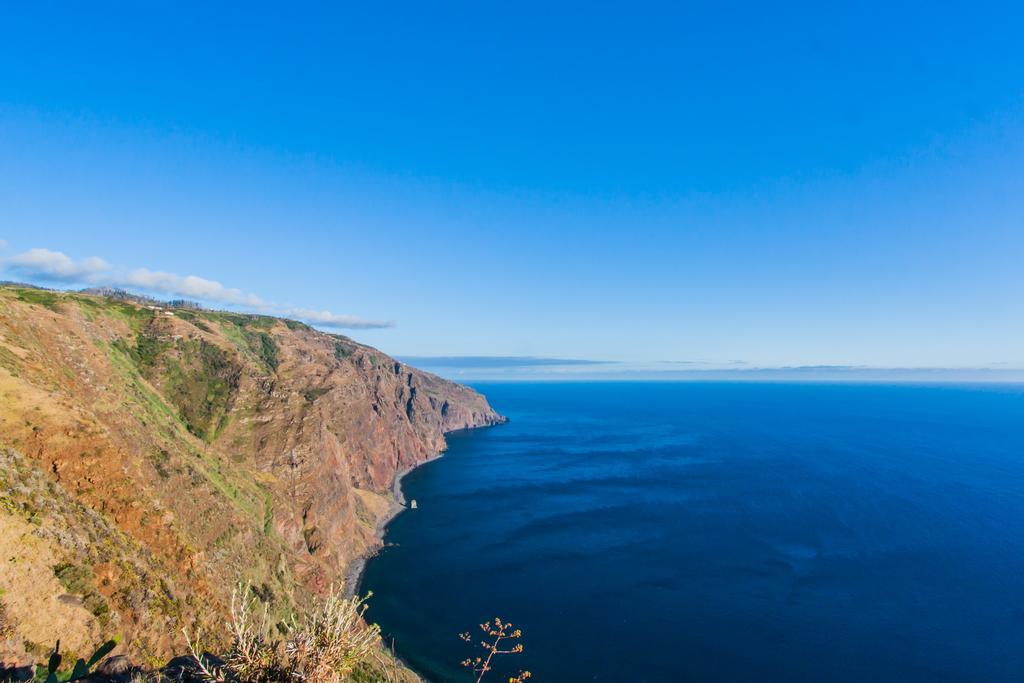Could you give a brief overview of what you see in this image? In this image we can see sky with clouds, ocean, plants and hill. 